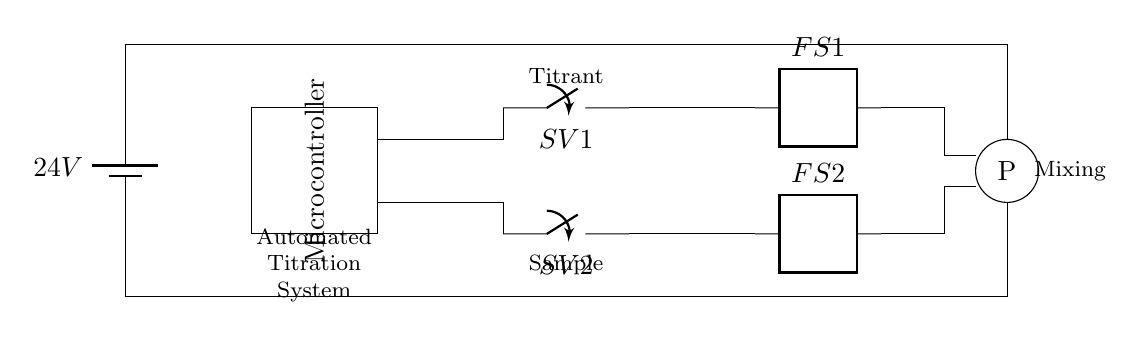What is the voltage of this circuit? The voltage is 24V, which is indicated by the battery symbol in the circuit. It shows the potential difference supplied to the circuit.
Answer: 24V What are the main components of this circuit? The main components include a microcontroller, solenoid valves, flow sensors, and a pump. These are all visible in their respective symbols in the circuit diagram.
Answer: Microcontroller, solenoid valves, flow sensors, pump How many solenoid valves are present in the circuit? There are two solenoid valves indicated by the labels SV1 and SV2 in the circuit diagram.
Answer: 2 What is the function of the flow sensors? The flow sensors (FS1 and FS2) are used to detect the flow of liquid within the automated titration system. Their presence indicates monitoring of the liquid path.
Answer: Monitoring flow Which component is labeled as "P" in the circuit? The component labeled "P" in the circuit diagram represents the pump, which is responsible for moving the titrant and sample liquid through the system.
Answer: Pump What is the relationship between the microcontroller and the solenoid valves? The microcontroller controls the solenoid valves (SV1 and SV2) to open or close, allowing for precise control of the titrant and sample delivery during titration processes.
Answer: Control 